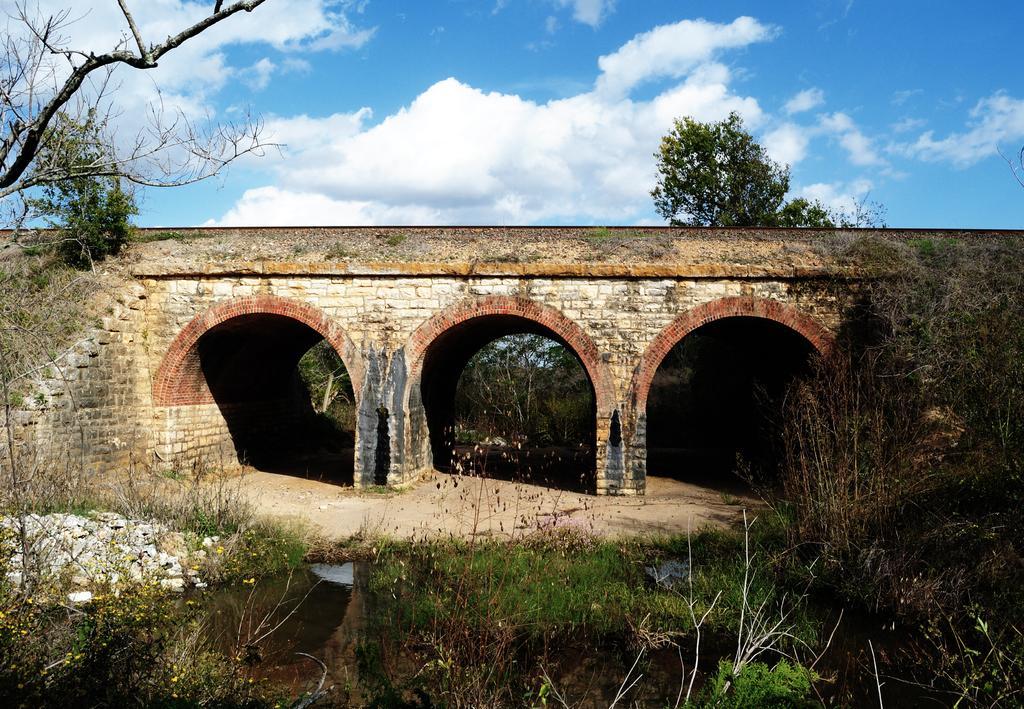Can you describe this image briefly? In the foreground of this image, there is water, grass, plants, stones and the trees. In the middle, there is a bridge and arches to it and we can also see trees and a plant. On the top, there is the sky and the cloud. 